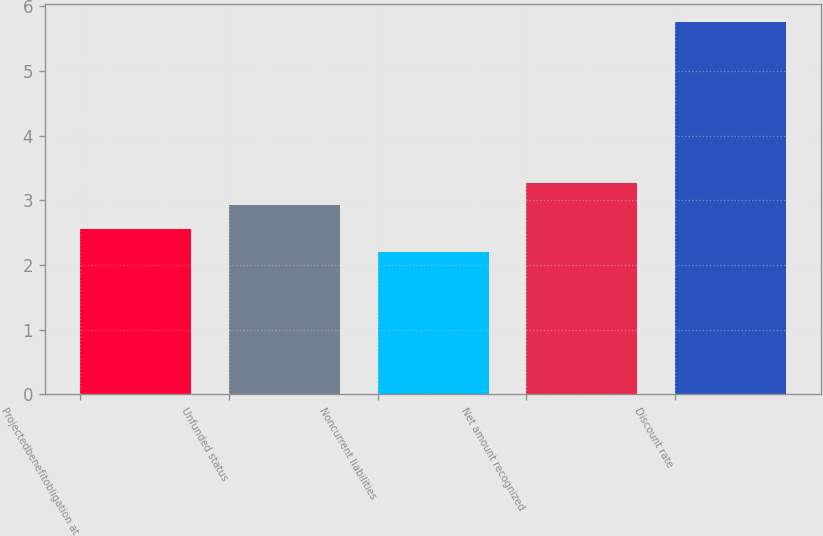Convert chart. <chart><loc_0><loc_0><loc_500><loc_500><bar_chart><fcel>Projectedbenefitobligation at<fcel>Unfunded status<fcel>Noncurrent liabilities<fcel>Net amount recognized<fcel>Discount rate<nl><fcel>2.56<fcel>2.92<fcel>2.2<fcel>3.27<fcel>5.75<nl></chart> 